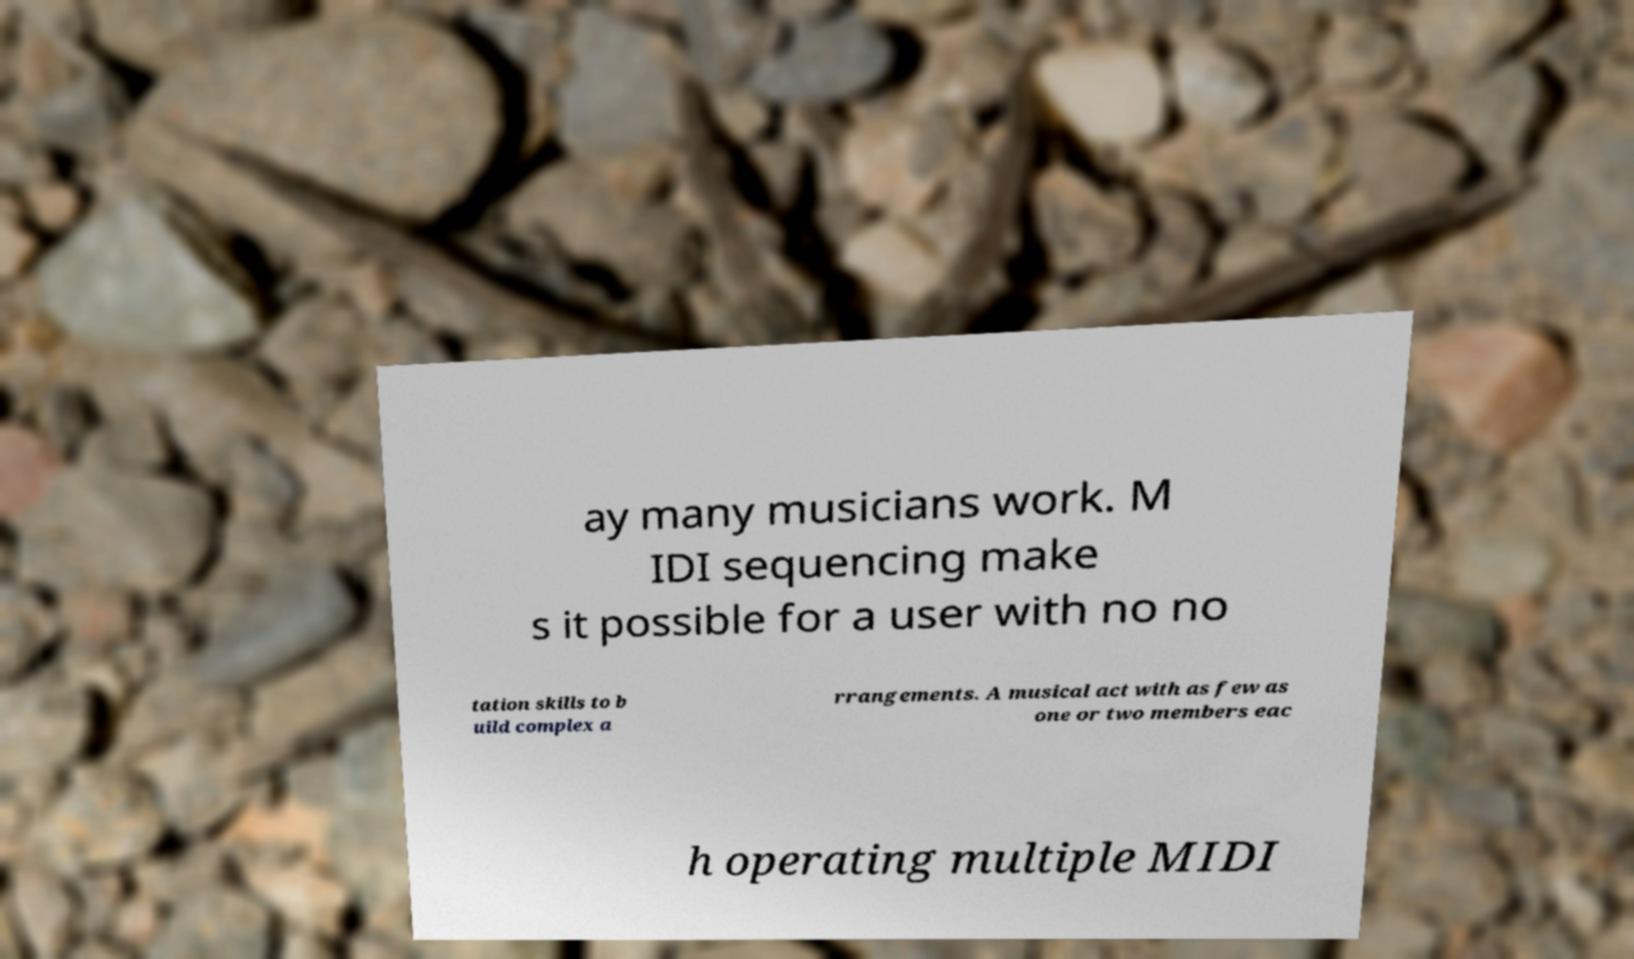Could you assist in decoding the text presented in this image and type it out clearly? ay many musicians work. M IDI sequencing make s it possible for a user with no no tation skills to b uild complex a rrangements. A musical act with as few as one or two members eac h operating multiple MIDI 